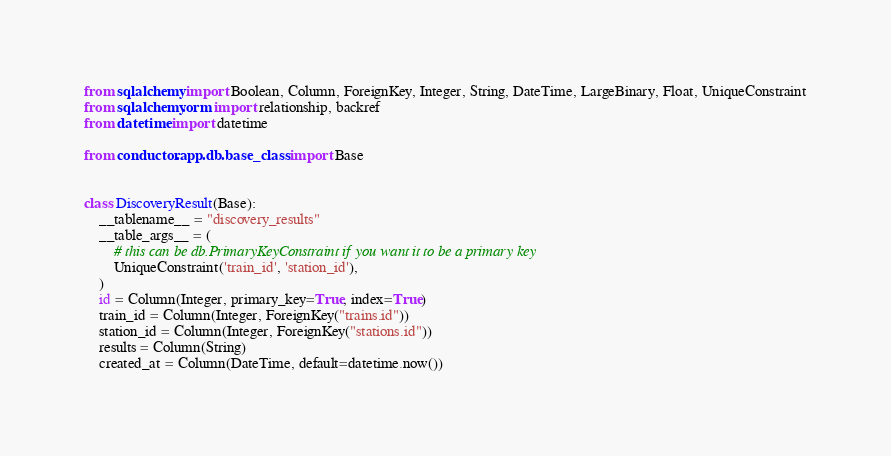Convert code to text. <code><loc_0><loc_0><loc_500><loc_500><_Python_>from sqlalchemy import Boolean, Column, ForeignKey, Integer, String, DateTime, LargeBinary, Float, UniqueConstraint
from sqlalchemy.orm import relationship, backref
from datetime import datetime

from conductor.app.db.base_class import Base


class DiscoveryResult(Base):
    __tablename__ = "discovery_results"
    __table_args__ = (
        # this can be db.PrimaryKeyConstraint if you want it to be a primary key
        UniqueConstraint('train_id', 'station_id'),
    )
    id = Column(Integer, primary_key=True, index=True)
    train_id = Column(Integer, ForeignKey("trains.id"))
    station_id = Column(Integer, ForeignKey("stations.id"))
    results = Column(String)
    created_at = Column(DateTime, default=datetime.now())
</code> 